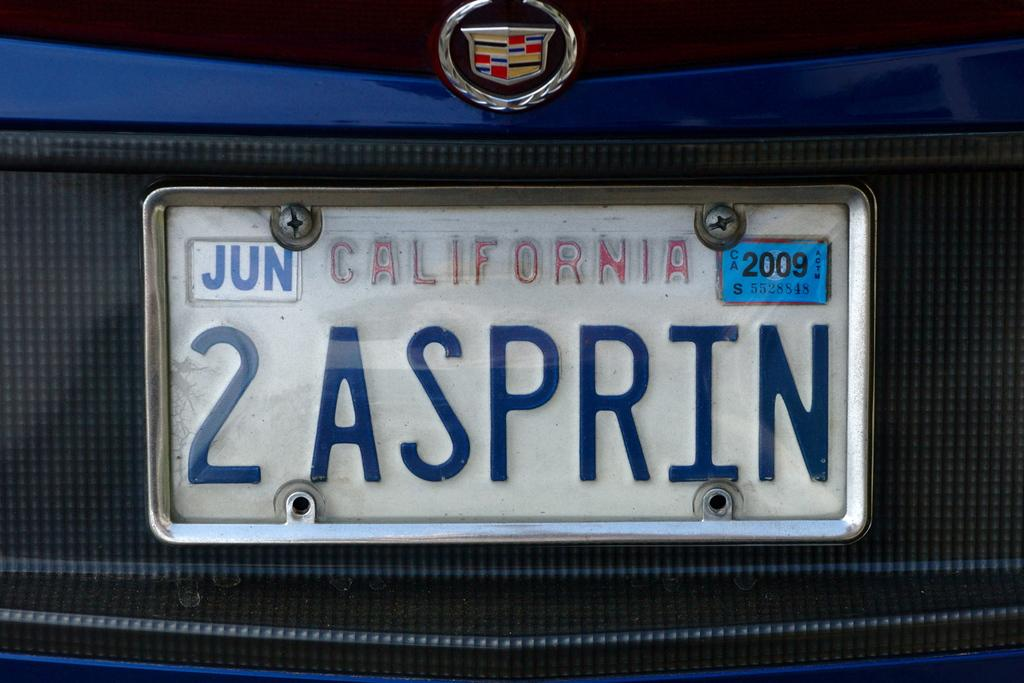<image>
Describe the image concisely. License plate from California that registration is valid until 2009 